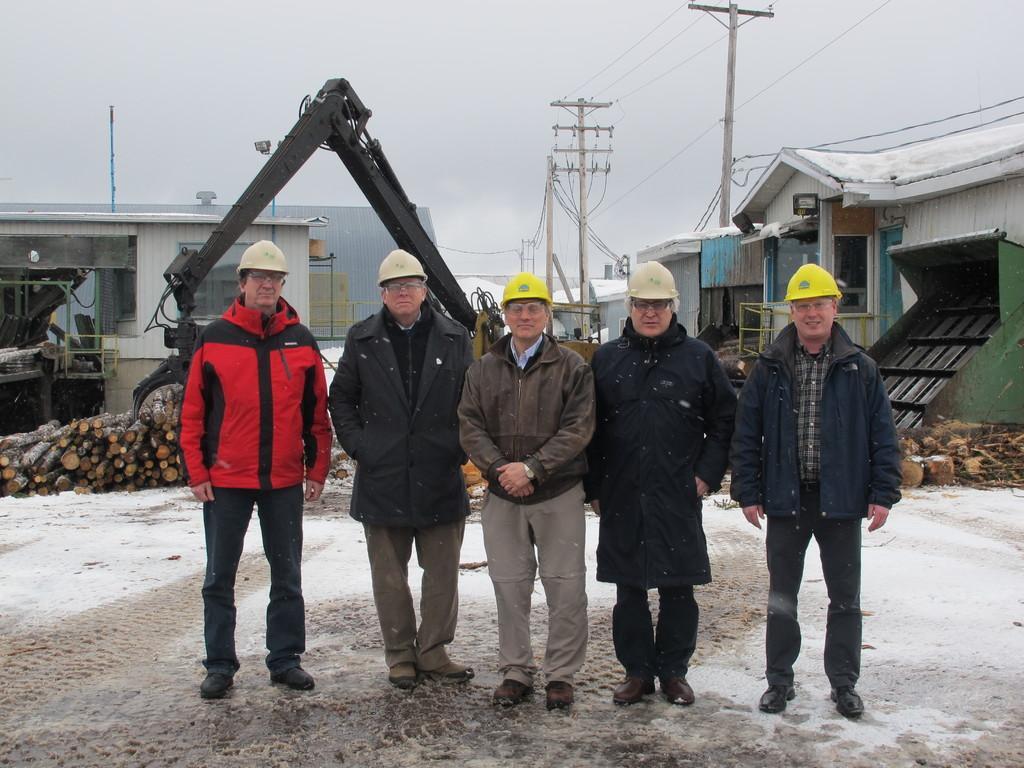How would you summarize this image in a sentence or two? In this image we can group of people wearing helmets are standing on the ground. In the center of the image we can see a vehicle and some wood logs. In the background, we can see a group of buildings with windows, light, railing, group of poles with cables and the sky. 